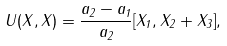<formula> <loc_0><loc_0><loc_500><loc_500>U ( X , X ) = \frac { a _ { 2 } - a _ { 1 } } { a _ { 2 } } [ X _ { 1 } , X _ { 2 } + X _ { 3 } ] ,</formula> 